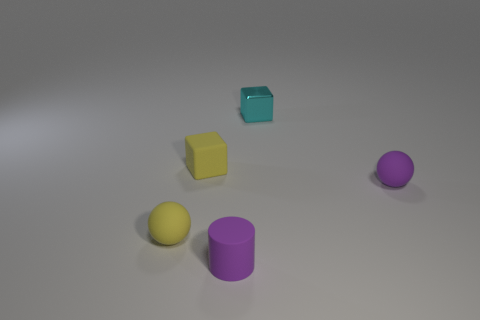Is the number of shiny objects in front of the small cyan metallic cube the same as the number of purple rubber cylinders behind the small matte cylinder?
Your answer should be very brief. Yes. How many cylinders have the same size as the cyan thing?
Give a very brief answer. 1. How many yellow things are cylinders or tiny things?
Your answer should be very brief. 2. Are there an equal number of cyan metallic blocks that are on the left side of the small cyan thing and tiny yellow blocks?
Give a very brief answer. No. How big is the purple matte object to the right of the tiny cyan shiny thing?
Your answer should be very brief. Small. What number of tiny green rubber things have the same shape as the shiny object?
Give a very brief answer. 0. What is the tiny thing that is behind the small purple matte ball and to the left of the shiny object made of?
Provide a succinct answer. Rubber. Do the yellow sphere and the small cyan thing have the same material?
Ensure brevity in your answer.  No. What number of tiny red rubber spheres are there?
Make the answer very short. 0. What is the color of the small ball to the right of the small purple object left of the small ball that is on the right side of the small metallic block?
Ensure brevity in your answer.  Purple. 